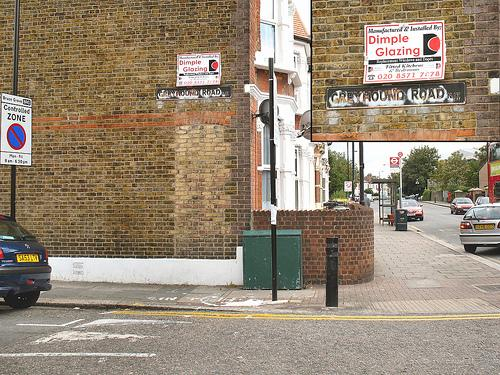Briefly explain the location and appearance of the business promotional sign. The business promotional sign is on the building with a white background and blue circle with a red line through it. What type of material is the building made of and what color is it? The building is made of brown brick material. Provide a brief description of the sidewalk and its placement in relation to the building. The brick paved sidewalk is on the side and front of the building. Explain the action performed by the silver car in the image. The silver car is pulling out of an entrance and away from the curb. How many cars are parked in the image and what colors are they? There are three parked cars: a blue car, a red car, and a silver car. What color is the hatchback sedan mentioned in the image? The hatchback sedan is blue in color. In what setting was the picture taken and during what time of day? The picture was taken outdoors during the day. Which cars are parked in the image, and what are their colors? A blue car, a red car, and a silver car are parked. Describe the position of the green box in the image. The green box is next to the wall. What is the color of the sidewalk in front of the building? The sidewalk is brick paved and grey. Read the text on the worn sign. Greyhound road What is the color of the license plate on the parked car? Black and yellow What is the mood of the people in the image? There are no people in the image. What type of information is provided by the blue and red sign in the image? Parking information Describe the cars' activity in the image. One car is parked, and another is pulling away from the curb. Explain the building's construction material and color. The building is made of brown brick. State the color of the license plate on the blue car. The license plate is yellow and black. Write down the text on the red, white, and black sign. Dimple Glazing What color is the car next to the green trashcan? red Describe the appearance of the wall as seen through the cutout. It is a zoomed-in, brown brick wall. Which of the following signs is seen in the image: (a) greyhound road, (b) dimple glazing, (c) parking information, or (d) pet store? (a) greyhound road, (b) dimple glazing, (c) parking information Is the picture taken indoors or outdoors, and what time of the day was it taken? The picture is taken outdoors during the day. Identify the color and style of the car that's pulling out of the entrance. The car is silver and a sedan. What type of object is sticking out from the sidewalk? A black pole What type of sign is on the black pole? A street sign Is the green box situated close to the sidewalk or next to the wall? Next to the wall 